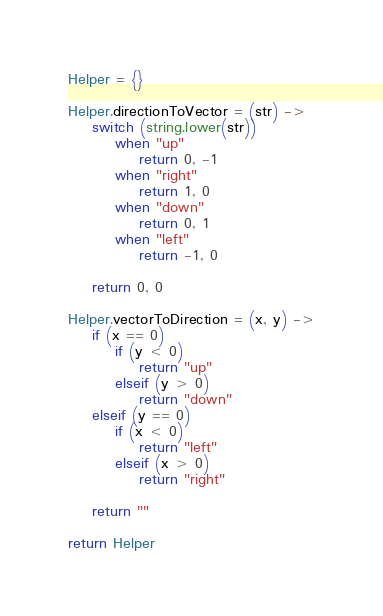<code> <loc_0><loc_0><loc_500><loc_500><_MoonScript_>Helper = {}

Helper.directionToVector = (str) ->
    switch (string.lower(str))
        when "up"
            return 0, -1
        when "right"
            return 1, 0
        when "down"
            return 0, 1
        when "left"
            return -1, 0

    return 0, 0

Helper.vectorToDirection = (x, y) ->
    if (x == 0)
        if (y < 0)
            return "up"
        elseif (y > 0)
            return "down"
    elseif (y == 0)
        if (x < 0)
            return "left"
        elseif (x > 0)
            return "right"

    return ""

return Helper
</code> 